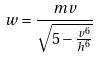Convert formula to latex. <formula><loc_0><loc_0><loc_500><loc_500>w = \frac { m v } { \sqrt { 5 - \frac { v ^ { 6 } } { h ^ { 6 } } } }</formula> 